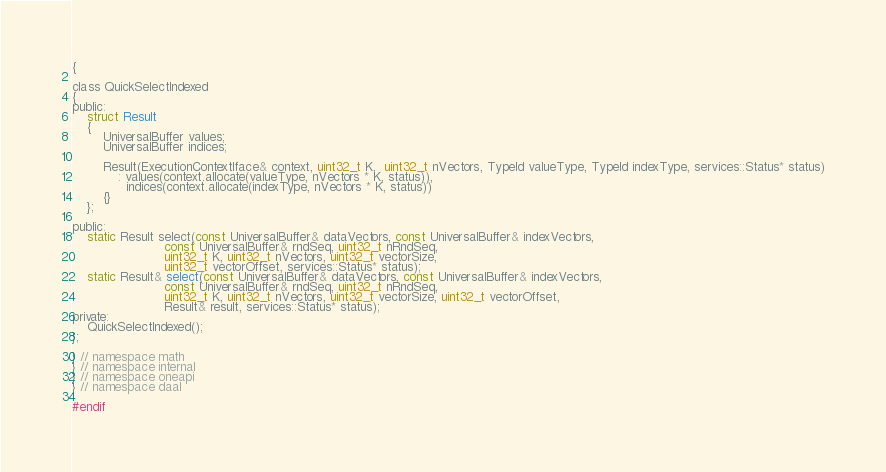<code> <loc_0><loc_0><loc_500><loc_500><_C_>{

class QuickSelectIndexed
{
public:
    struct Result
    {
        UniversalBuffer values;
        UniversalBuffer indices;

        Result(ExecutionContextIface& context, uint32_t K,  uint32_t nVectors, TypeId valueType, TypeId indexType, services::Status* status)
            : values(context.allocate(valueType, nVectors * K, status)),
              indices(context.allocate(indexType, nVectors * K, status))
        {}
    };

public:
    static Result select(const UniversalBuffer& dataVectors, const UniversalBuffer& indexVectors,
                        const UniversalBuffer& rndSeq, uint32_t nRndSeq,
                        uint32_t K, uint32_t nVectors, uint32_t vectorSize,
                        uint32_t vectorOffset, services::Status* status);
    static Result& select(const UniversalBuffer& dataVectors, const UniversalBuffer& indexVectors,
                        const UniversalBuffer& rndSeq, uint32_t nRndSeq,
                        uint32_t K, uint32_t nVectors, uint32_t vectorSize, uint32_t vectorOffset,
                        Result& result, services::Status* status);
private:
    QuickSelectIndexed();
};

} // namespace math
} // namespace internal
} // namespace oneapi
} // namespace daal

#endif
</code> 